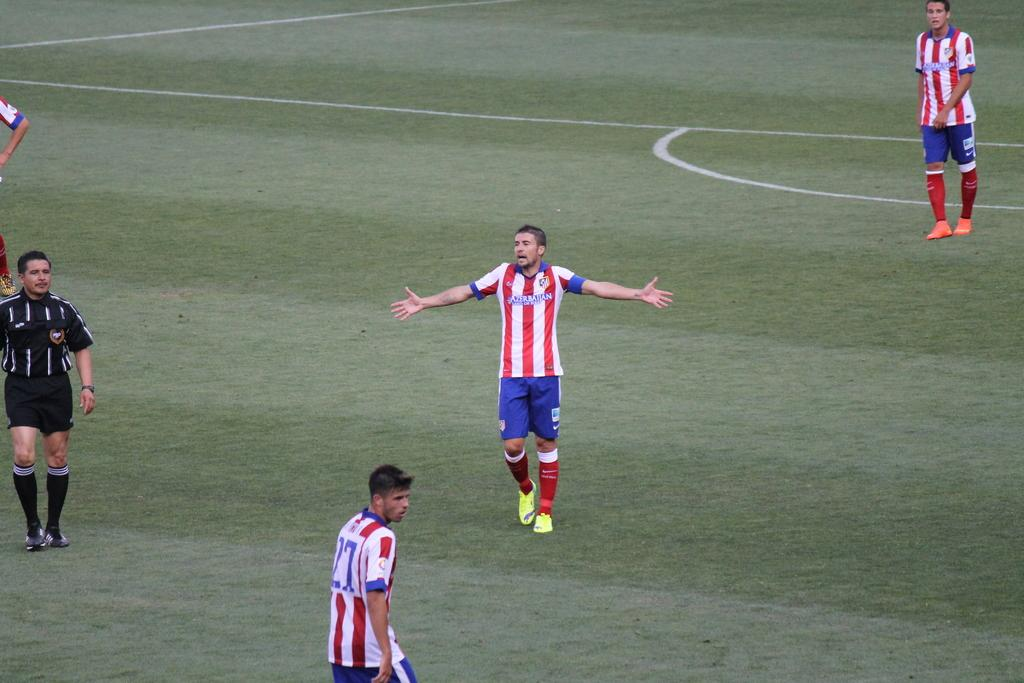How many people are in the image? The number of people in the image cannot be determined from the given fact. What type of garden can be seen in the image? There is no garden present in the image, as the fact only mentions the presence of people. 